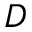Convert formula to latex. <formula><loc_0><loc_0><loc_500><loc_500>D</formula> 